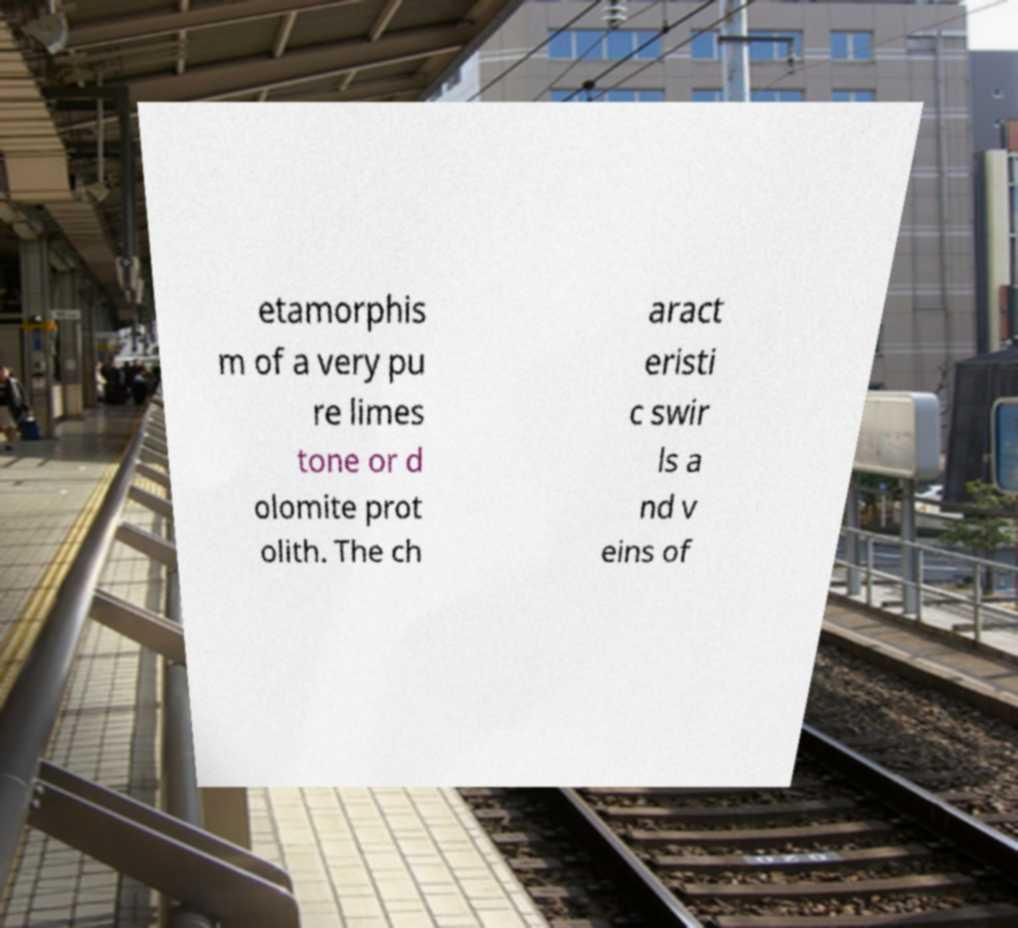Please identify and transcribe the text found in this image. etamorphis m of a very pu re limes tone or d olomite prot olith. The ch aract eristi c swir ls a nd v eins of 